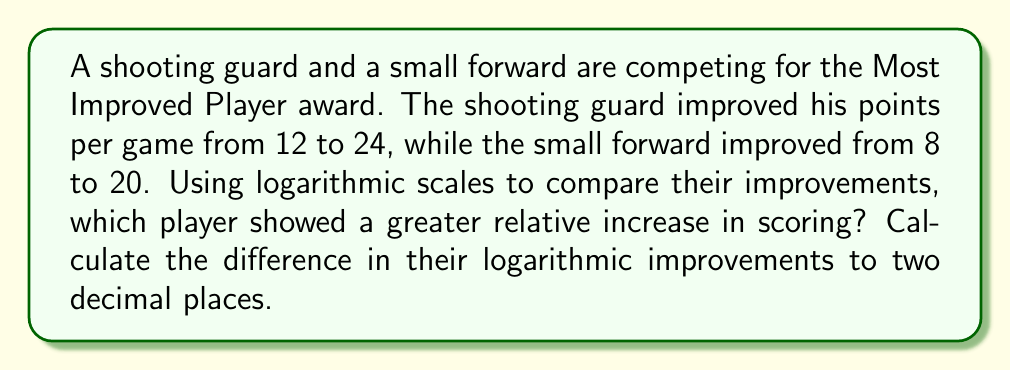Teach me how to tackle this problem. To compare the relative improvements using logarithmic scales, we'll use the formula:

Logarithmic improvement = $\log(\text{final value}) - \log(\text{initial value})$

For the shooting guard:
$\log(24) - \log(12) = \log(\frac{24}{12}) = \log(2) \approx 0.301$

For the small forward:
$\log(20) - \log(8) = \log(\frac{20}{8}) = \log(2.5) \approx 0.398$

To find the difference in their logarithmic improvements:
$0.398 - 0.301 = 0.097$

Rounding to two decimal places: 0.10

Since the small forward's logarithmic improvement is greater, they showed a greater relative increase in scoring.
Answer: 0.10 